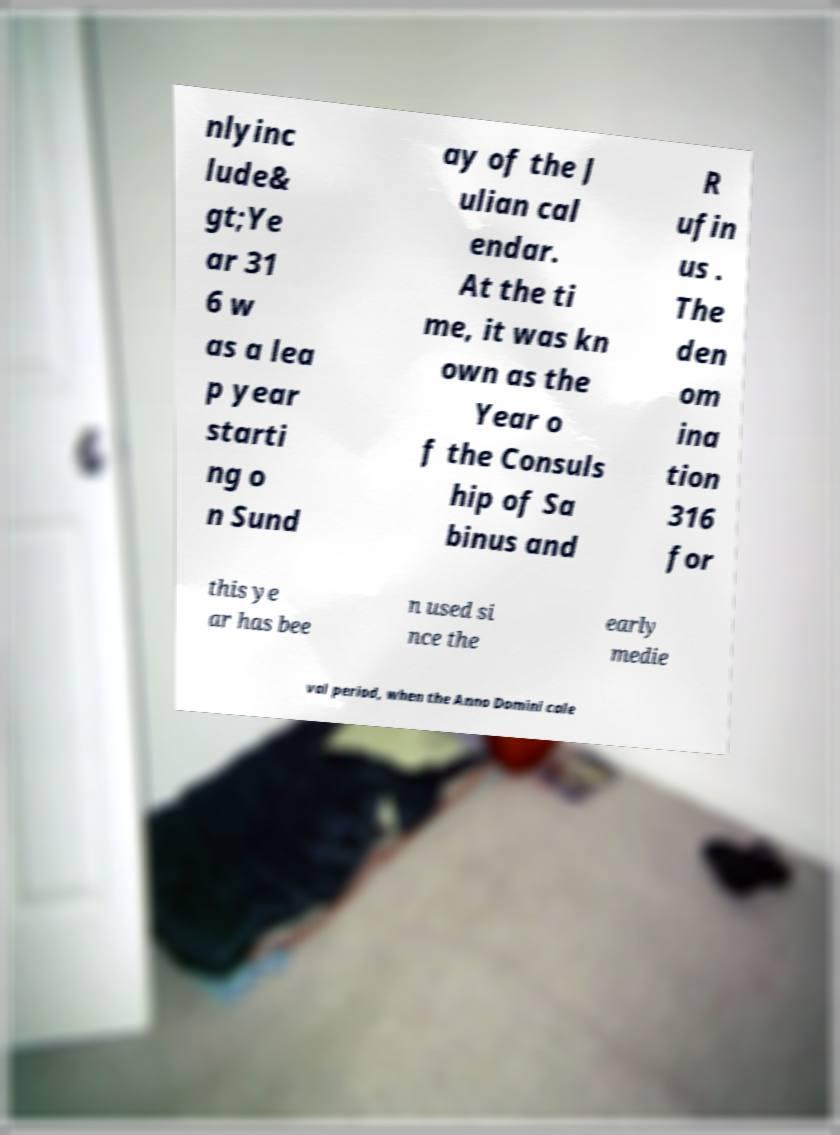For documentation purposes, I need the text within this image transcribed. Could you provide that? nlyinc lude& gt;Ye ar 31 6 w as a lea p year starti ng o n Sund ay of the J ulian cal endar. At the ti me, it was kn own as the Year o f the Consuls hip of Sa binus and R ufin us . The den om ina tion 316 for this ye ar has bee n used si nce the early medie val period, when the Anno Domini cale 